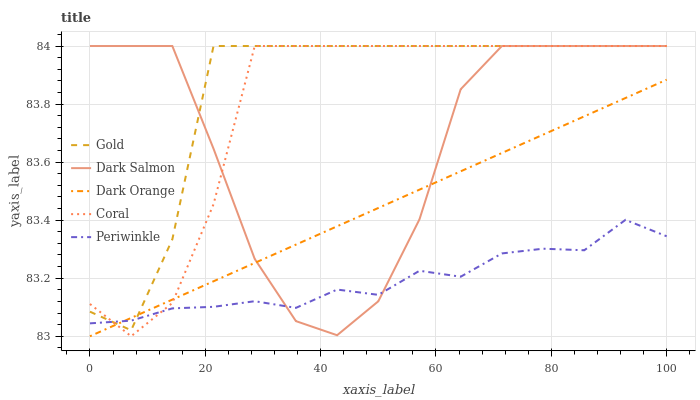Does Periwinkle have the minimum area under the curve?
Answer yes or no. Yes. Does Gold have the maximum area under the curve?
Answer yes or no. Yes. Does Coral have the minimum area under the curve?
Answer yes or no. No. Does Coral have the maximum area under the curve?
Answer yes or no. No. Is Dark Orange the smoothest?
Answer yes or no. Yes. Is Dark Salmon the roughest?
Answer yes or no. Yes. Is Coral the smoothest?
Answer yes or no. No. Is Coral the roughest?
Answer yes or no. No. Does Dark Orange have the lowest value?
Answer yes or no. Yes. Does Coral have the lowest value?
Answer yes or no. No. Does Gold have the highest value?
Answer yes or no. Yes. Does Periwinkle have the highest value?
Answer yes or no. No. Does Dark Salmon intersect Coral?
Answer yes or no. Yes. Is Dark Salmon less than Coral?
Answer yes or no. No. Is Dark Salmon greater than Coral?
Answer yes or no. No. 